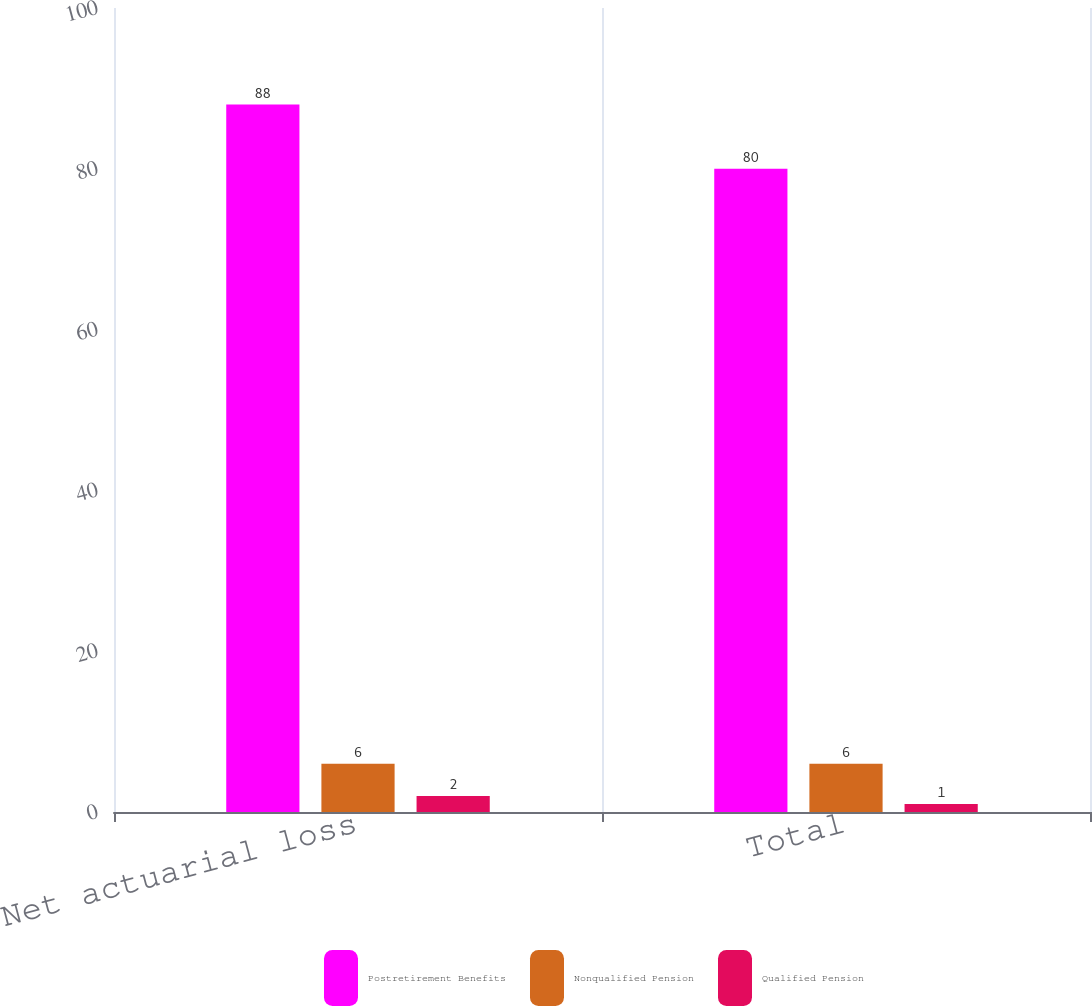Convert chart. <chart><loc_0><loc_0><loc_500><loc_500><stacked_bar_chart><ecel><fcel>Net actuarial loss<fcel>Total<nl><fcel>Postretirement Benefits<fcel>88<fcel>80<nl><fcel>Nonqualified Pension<fcel>6<fcel>6<nl><fcel>Qualified Pension<fcel>2<fcel>1<nl></chart> 